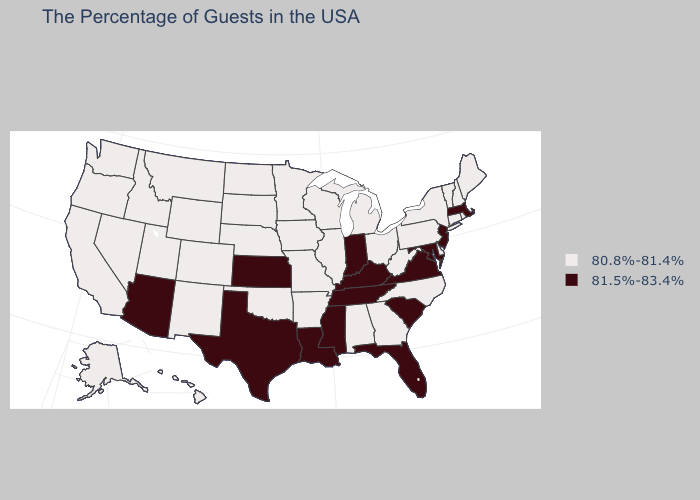Name the states that have a value in the range 80.8%-81.4%?
Give a very brief answer. Maine, Rhode Island, New Hampshire, Vermont, Connecticut, New York, Delaware, Pennsylvania, North Carolina, West Virginia, Ohio, Georgia, Michigan, Alabama, Wisconsin, Illinois, Missouri, Arkansas, Minnesota, Iowa, Nebraska, Oklahoma, South Dakota, North Dakota, Wyoming, Colorado, New Mexico, Utah, Montana, Idaho, Nevada, California, Washington, Oregon, Alaska, Hawaii. Which states have the highest value in the USA?
Short answer required. Massachusetts, New Jersey, Maryland, Virginia, South Carolina, Florida, Kentucky, Indiana, Tennessee, Mississippi, Louisiana, Kansas, Texas, Arizona. What is the lowest value in the Northeast?
Answer briefly. 80.8%-81.4%. Which states have the lowest value in the Northeast?
Write a very short answer. Maine, Rhode Island, New Hampshire, Vermont, Connecticut, New York, Pennsylvania. Does Delaware have the same value as Maine?
Quick response, please. Yes. Is the legend a continuous bar?
Be succinct. No. Does New York have the highest value in the Northeast?
Give a very brief answer. No. Among the states that border Nebraska , which have the lowest value?
Short answer required. Missouri, Iowa, South Dakota, Wyoming, Colorado. Does Maine have the lowest value in the USA?
Keep it brief. Yes. Does the map have missing data?
Write a very short answer. No. Does Vermont have the same value as Tennessee?
Give a very brief answer. No. Name the states that have a value in the range 81.5%-83.4%?
Give a very brief answer. Massachusetts, New Jersey, Maryland, Virginia, South Carolina, Florida, Kentucky, Indiana, Tennessee, Mississippi, Louisiana, Kansas, Texas, Arizona. Among the states that border New Hampshire , which have the lowest value?
Keep it brief. Maine, Vermont. Does Kentucky have the highest value in the USA?
Write a very short answer. Yes. Does Alaska have a lower value than Louisiana?
Write a very short answer. Yes. 